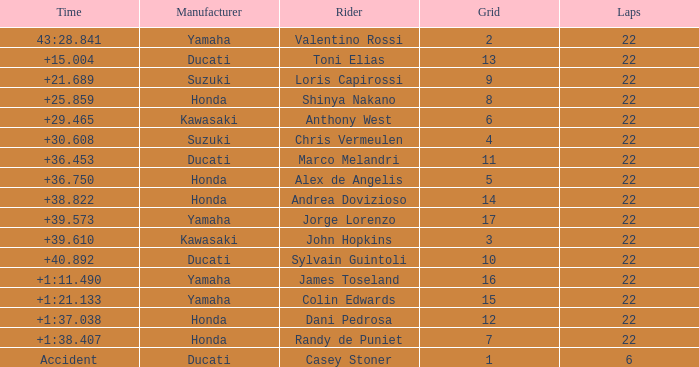What laps did Honda do with a time of +1:38.407? 22.0. 